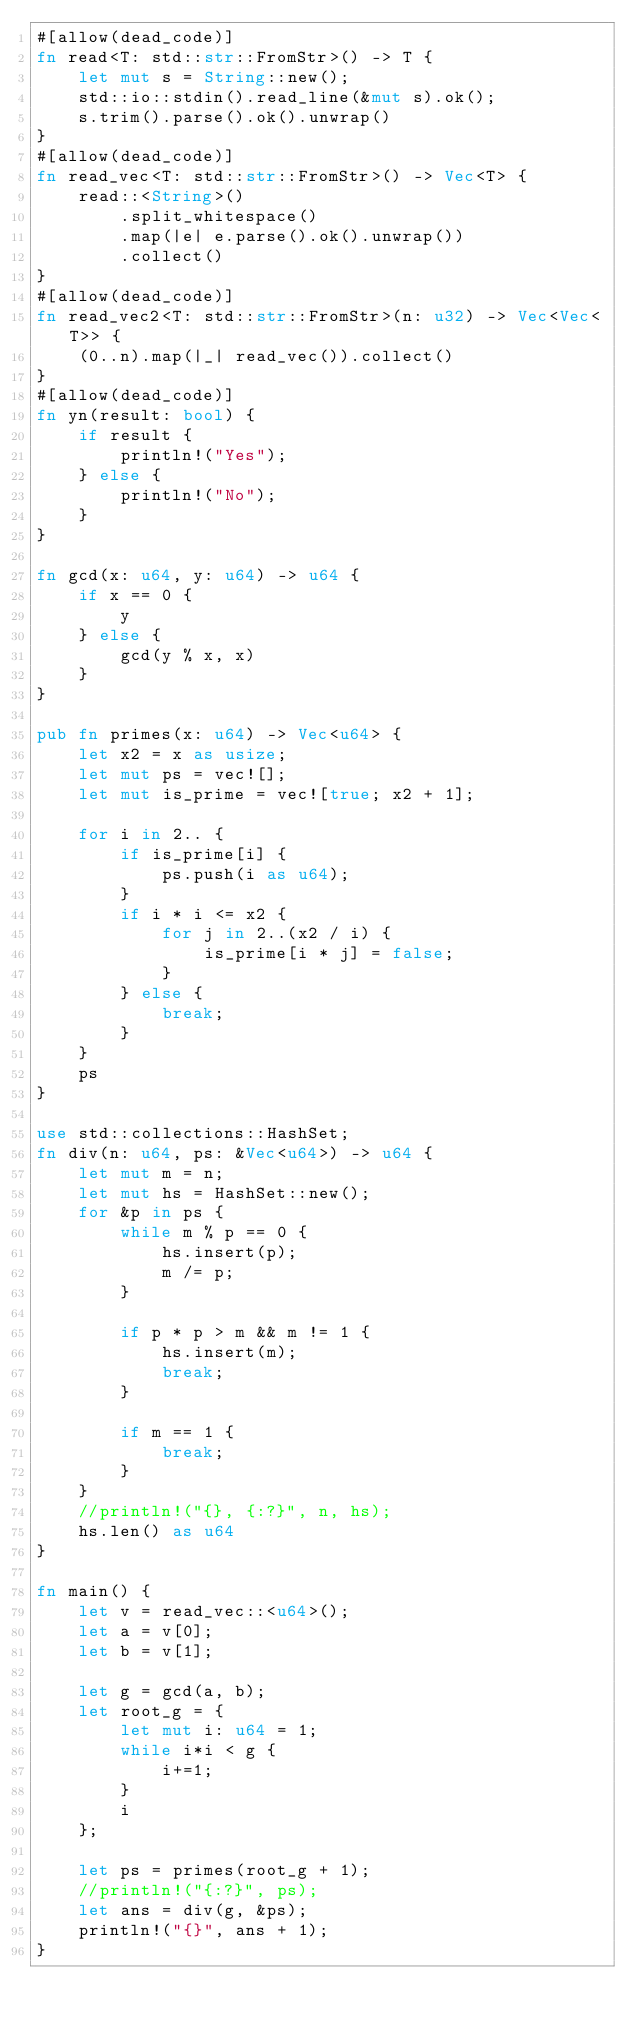<code> <loc_0><loc_0><loc_500><loc_500><_Rust_>#[allow(dead_code)]
fn read<T: std::str::FromStr>() -> T {
    let mut s = String::new();
    std::io::stdin().read_line(&mut s).ok();
    s.trim().parse().ok().unwrap()
}
#[allow(dead_code)]
fn read_vec<T: std::str::FromStr>() -> Vec<T> {
    read::<String>()
        .split_whitespace()
        .map(|e| e.parse().ok().unwrap())
        .collect()
}
#[allow(dead_code)]
fn read_vec2<T: std::str::FromStr>(n: u32) -> Vec<Vec<T>> {
    (0..n).map(|_| read_vec()).collect()
}
#[allow(dead_code)]
fn yn(result: bool) {
    if result {
        println!("Yes");
    } else {
        println!("No");
    }
}

fn gcd(x: u64, y: u64) -> u64 {
    if x == 0 {
        y
    } else {
        gcd(y % x, x)
    }
}

pub fn primes(x: u64) -> Vec<u64> {
    let x2 = x as usize;
    let mut ps = vec![];
    let mut is_prime = vec![true; x2 + 1];

    for i in 2.. {
        if is_prime[i] {
            ps.push(i as u64);
        }
        if i * i <= x2 {
            for j in 2..(x2 / i) {
                is_prime[i * j] = false;
            }
        } else {
            break;
        }
    }
    ps
}

use std::collections::HashSet;
fn div(n: u64, ps: &Vec<u64>) -> u64 {
    let mut m = n;
    let mut hs = HashSet::new();
    for &p in ps {
        while m % p == 0 {
            hs.insert(p);
            m /= p;
        }

        if p * p > m && m != 1 {
            hs.insert(m);
            break;
        }

        if m == 1 {
            break;
        }
    }
    //println!("{}, {:?}", n, hs);
    hs.len() as u64
}

fn main() {
    let v = read_vec::<u64>();
    let a = v[0];
    let b = v[1];

    let g = gcd(a, b);
    let root_g = {
        let mut i: u64 = 1;
        while i*i < g {
            i+=1;
        }
        i
    };

    let ps = primes(root_g + 1);
    //println!("{:?}", ps);
    let ans = div(g, &ps);
    println!("{}", ans + 1);
}
</code> 